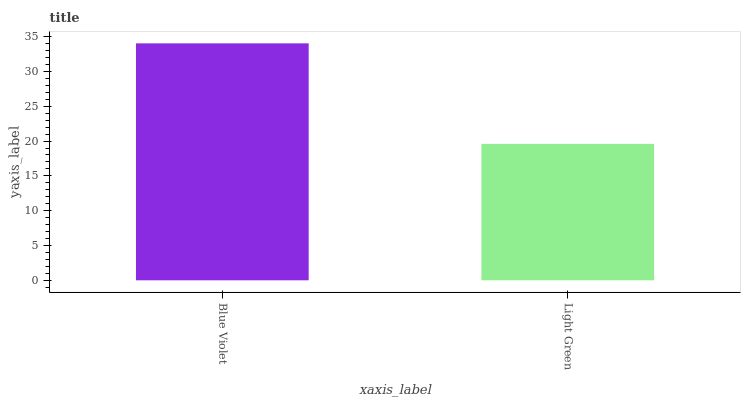Is Light Green the maximum?
Answer yes or no. No. Is Blue Violet greater than Light Green?
Answer yes or no. Yes. Is Light Green less than Blue Violet?
Answer yes or no. Yes. Is Light Green greater than Blue Violet?
Answer yes or no. No. Is Blue Violet less than Light Green?
Answer yes or no. No. Is Blue Violet the high median?
Answer yes or no. Yes. Is Light Green the low median?
Answer yes or no. Yes. Is Light Green the high median?
Answer yes or no. No. Is Blue Violet the low median?
Answer yes or no. No. 